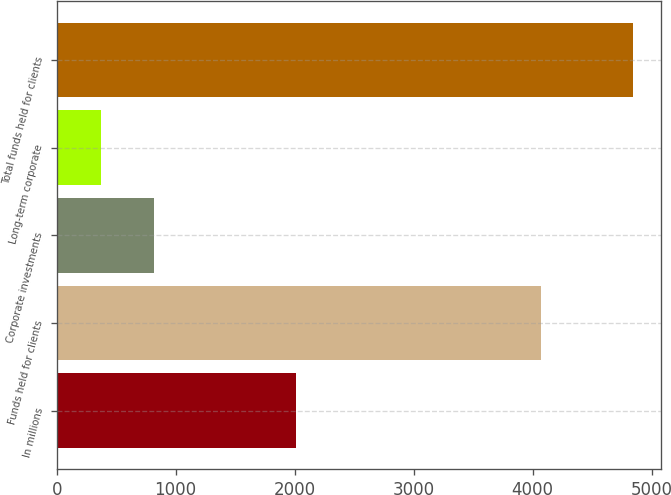Convert chart to OTSL. <chart><loc_0><loc_0><loc_500><loc_500><bar_chart><fcel>In millions<fcel>Funds held for clients<fcel>Corporate investments<fcel>Long-term corporate<fcel>Total funds held for clients<nl><fcel>2013<fcel>4072.5<fcel>816.17<fcel>369.1<fcel>4839.8<nl></chart> 